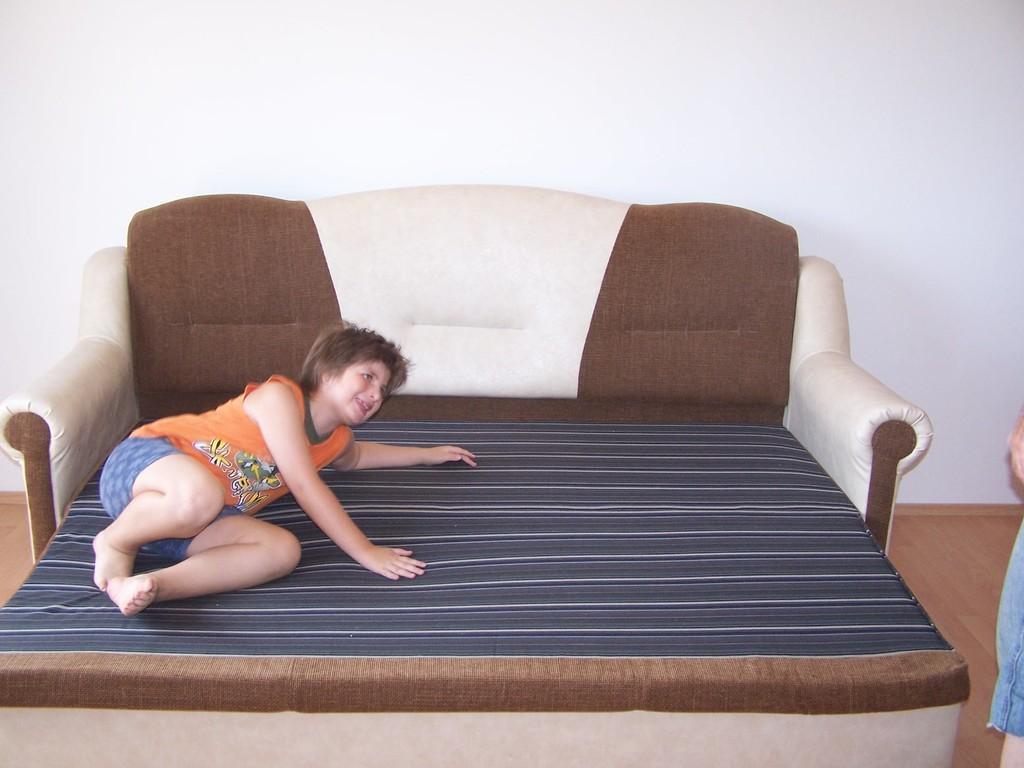Can you describe this image briefly? A lady is lying on a bed. It is a bed cum sofa. In the background there is a wall. 